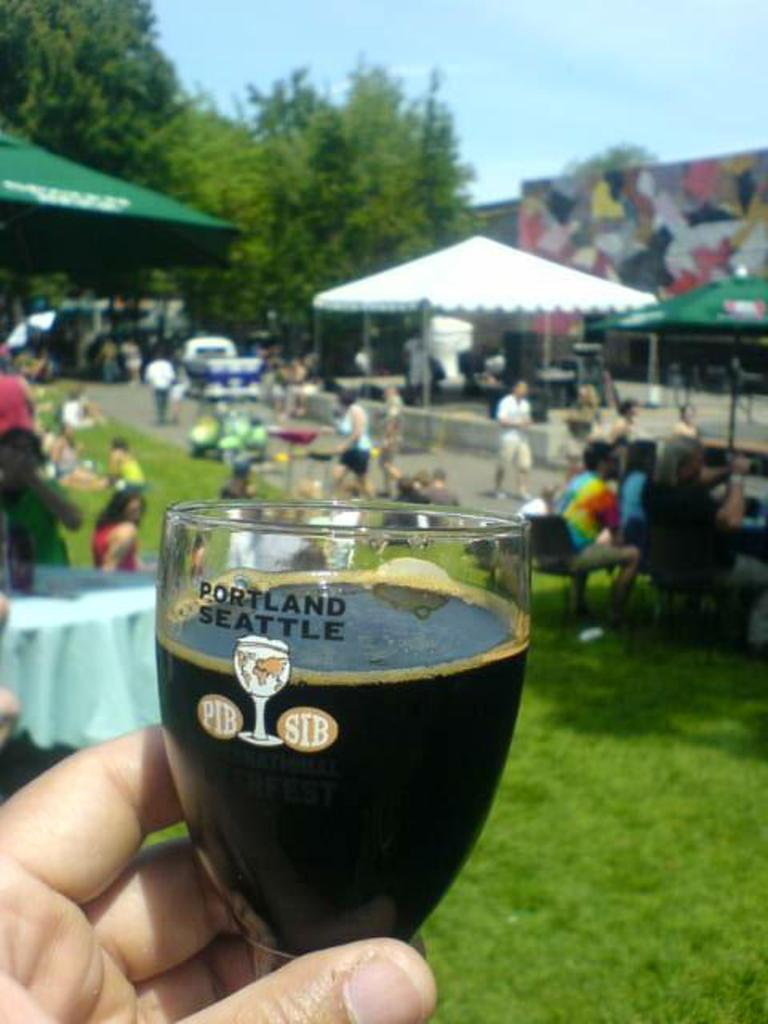<image>
Describe the image concisely. A person holding a glass that says Portland Seattle. 